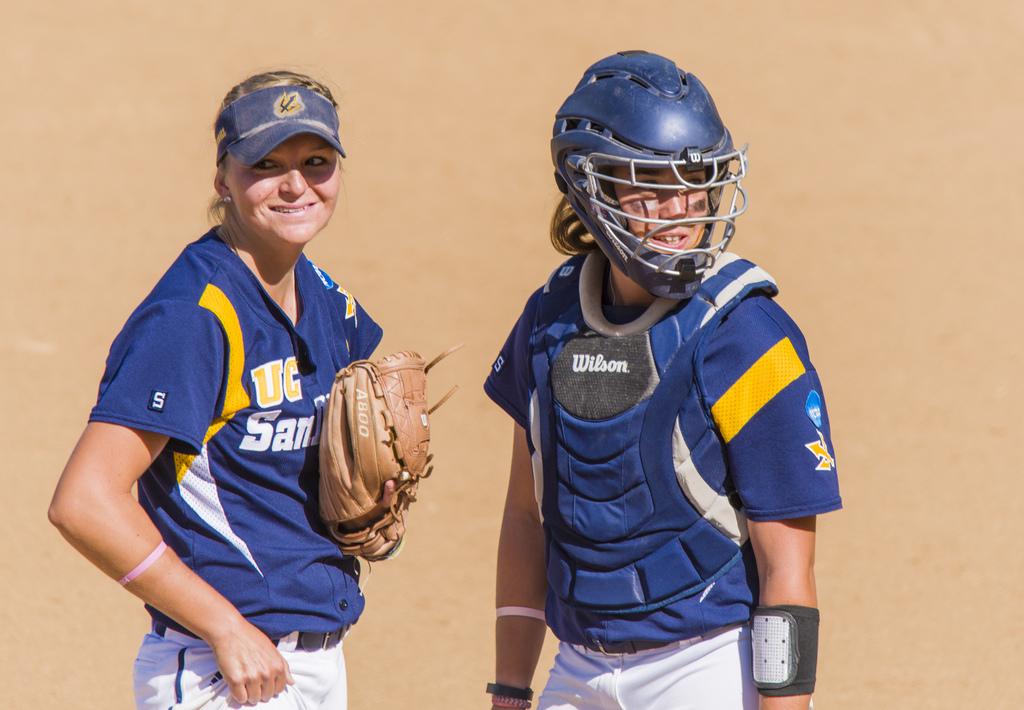What single letter is on the fielder's sleeve?
Ensure brevity in your answer.  S. 